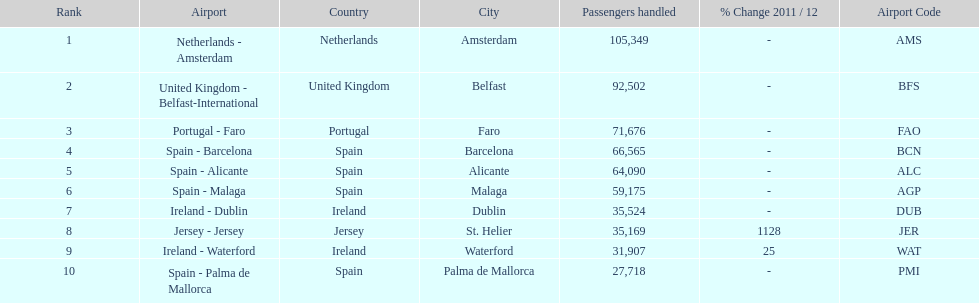Name all the london southend airports that did not list a change in 2001/12. Netherlands - Amsterdam, United Kingdom - Belfast-International, Portugal - Faro, Spain - Barcelona, Spain - Alicante, Spain - Malaga, Ireland - Dublin, Spain - Palma de Mallorca. I'm looking to parse the entire table for insights. Could you assist me with that? {'header': ['Rank', 'Airport', 'Country', 'City', 'Passengers handled', '% Change 2011 / 12', 'Airport Code'], 'rows': [['1', 'Netherlands - Amsterdam', 'Netherlands', 'Amsterdam', '105,349', '-', 'AMS'], ['2', 'United Kingdom - Belfast-International', 'United Kingdom', 'Belfast', '92,502', '-', 'BFS'], ['3', 'Portugal - Faro', 'Portugal', 'Faro', '71,676', '-', 'FAO'], ['4', 'Spain - Barcelona', 'Spain', 'Barcelona', '66,565', '-', 'BCN'], ['5', 'Spain - Alicante', 'Spain', 'Alicante', '64,090', '-', 'ALC'], ['6', 'Spain - Malaga', 'Spain', 'Malaga', '59,175', '-', 'AGP'], ['7', 'Ireland - Dublin', 'Ireland', 'Dublin', '35,524', '-', 'DUB'], ['8', 'Jersey - Jersey', 'Jersey', 'St. Helier', '35,169', '1128', 'JER'], ['9', 'Ireland - Waterford', 'Ireland', 'Waterford', '31,907', '25', 'WAT'], ['10', 'Spain - Palma de Mallorca', 'Spain', 'Palma de Mallorca', '27,718', '-', 'PMI']]} What unchanged percentage airports from 2011/12 handled less then 50,000 passengers? Ireland - Dublin, Spain - Palma de Mallorca. What unchanged percentage airport from 2011/12 handled less then 50,000 passengers is the closest to the equator? Spain - Palma de Mallorca. 